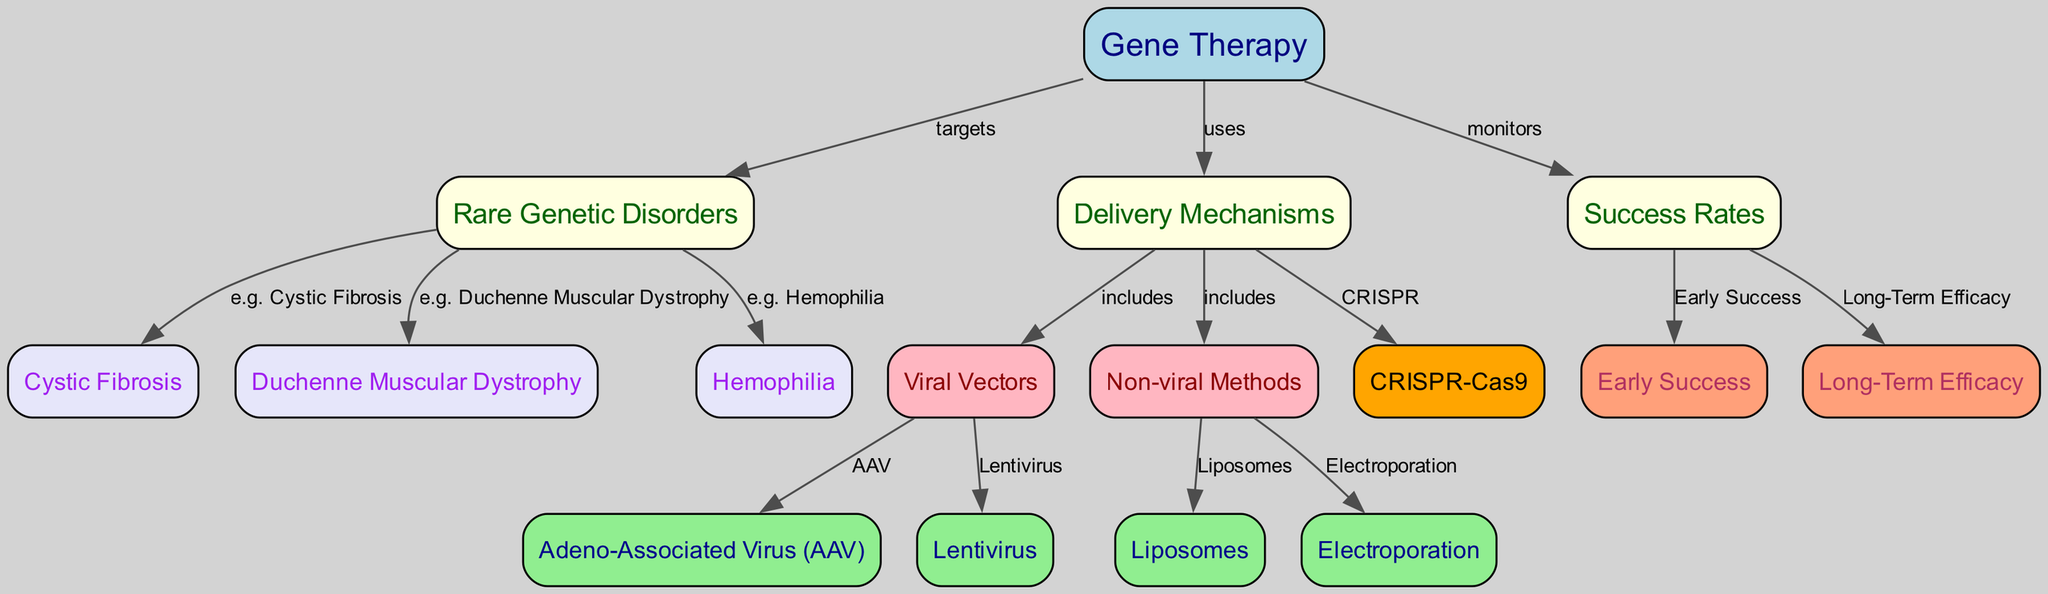What is the main focus of the diagram? The diagram primarily illustrates the relationship between gene therapy and its application in rare genetic disorders, as indicated by the direct connection (edge) from "Gene Therapy" to "Rare Genetic Disorders."
Answer: Gene Therapy How many delivery mechanisms are mentioned in the diagram? By counting the specific mechanisms listed under "Delivery Mechanisms," which include Viral Vectors and Non-viral Methods, we can see that there are four delivery mechanisms under the respective subcategories.
Answer: Four What is one example of a rare genetic disorder mentioned in the diagram? The edge from "Rare Genetic Disorders" to "Cystic Fibrosis" indicates that Cystic Fibrosis is an example of a disorder addressed by gene therapy.
Answer: Cystic Fibrosis Which delivery mechanism includes the use of Adeno-Associated Virus? The edge from "Viral Vectors" to "Adeno-Associated Virus (AAV)" makes clear that AAV is a type of delivery mechanism categorized under Viral Vectors.
Answer: Viral Vectors What type of efficacy is monitored under success rates? The diagram connects the "Success Rates" to both "Early Success" and "Long-Term Efficacy," indicating that these two types of efficacy are monitored.
Answer: Early Success, Long-Term Efficacy What is one of the non-viral methods mentioned for delivering gene therapy? The edge from "Non-viral Methods" to "Liposomes" illustrates that Liposomes represent a non-viral delivery method for gene therapy.
Answer: Liposomes Which mechanism is related to CRISPR technology in the diagram? The explicit connection from "Delivery Mechanisms" to "CRISPR-Cas9" shows that CRISPR-Cas9 is considered a mechanism of gene therapy delivery.
Answer: CRISPR-Cas9 Which two genetic disorders are directly linked to gene therapy in the diagram? By examining the edges from "Rare Genetic Disorders," we find that "Duchenne Muscular Dystrophy" and "Hemophilia" are both mentioned as disorders that gene therapy targets.
Answer: Duchenne Muscular Dystrophy, Hemophilia 